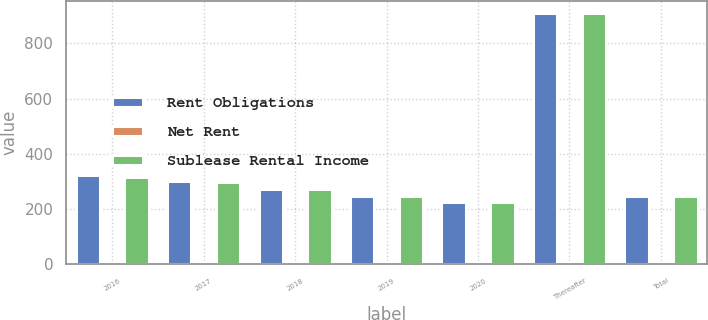Convert chart to OTSL. <chart><loc_0><loc_0><loc_500><loc_500><stacked_bar_chart><ecel><fcel>2016<fcel>2017<fcel>2018<fcel>2019<fcel>2020<fcel>Thereafter<fcel>Total<nl><fcel>Rent Obligations<fcel>322<fcel>300.4<fcel>272.2<fcel>246.1<fcel>224.5<fcel>909<fcel>245.4<nl><fcel>Net Rent<fcel>4.4<fcel>1.9<fcel>0.8<fcel>0.7<fcel>0<fcel>0<fcel>7.8<nl><fcel>Sublease Rental Income<fcel>317.6<fcel>298.5<fcel>271.4<fcel>245.4<fcel>224.5<fcel>909<fcel>245.4<nl></chart> 